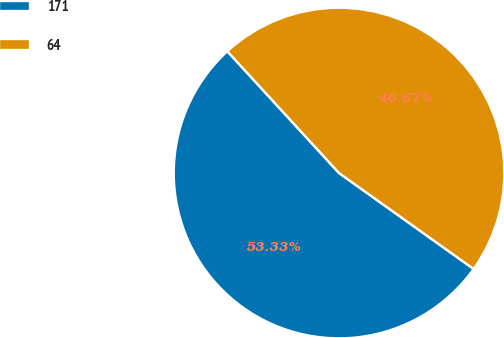<chart> <loc_0><loc_0><loc_500><loc_500><pie_chart><fcel>171<fcel>64<nl><fcel>53.33%<fcel>46.67%<nl></chart> 